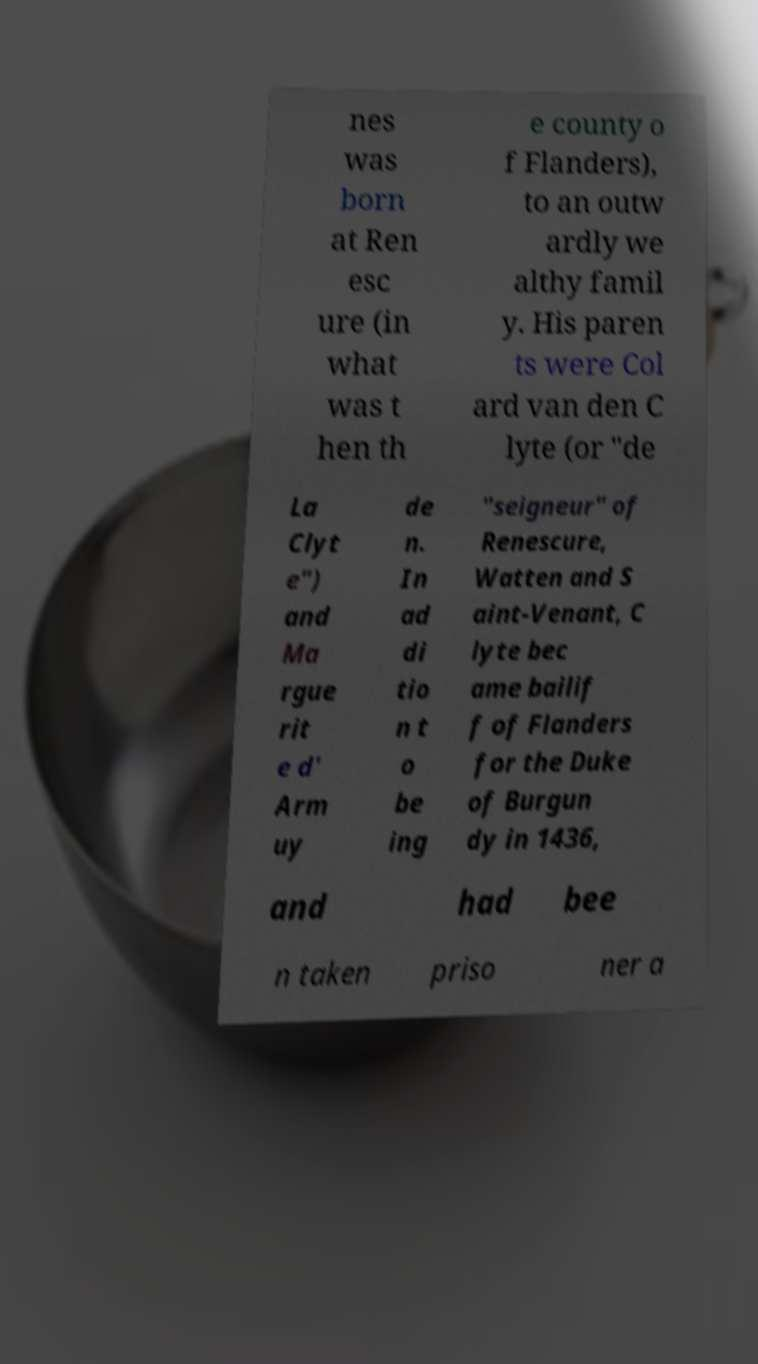Please read and relay the text visible in this image. What does it say? nes was born at Ren esc ure (in what was t hen th e county o f Flanders), to an outw ardly we althy famil y. His paren ts were Col ard van den C lyte (or "de La Clyt e") and Ma rgue rit e d' Arm uy de n. In ad di tio n t o be ing "seigneur" of Renescure, Watten and S aint-Venant, C lyte bec ame bailif f of Flanders for the Duke of Burgun dy in 1436, and had bee n taken priso ner a 